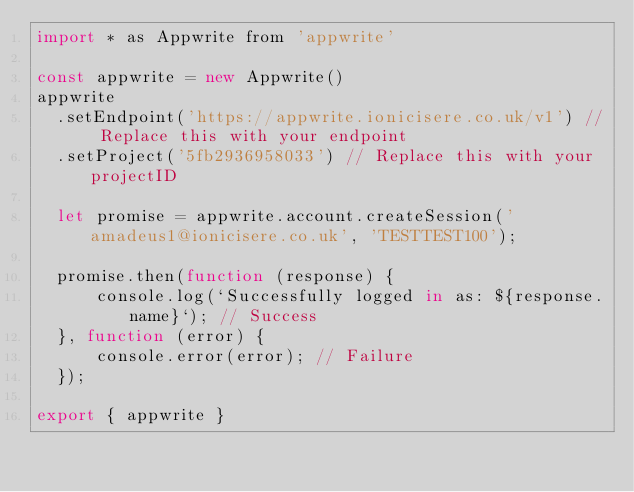<code> <loc_0><loc_0><loc_500><loc_500><_JavaScript_>import * as Appwrite from 'appwrite'

const appwrite = new Appwrite()
appwrite
  .setEndpoint('https://appwrite.ionicisere.co.uk/v1') // Replace this with your endpoint
  .setProject('5fb2936958033') // Replace this with your projectID

  let promise = appwrite.account.createSession('amadeus1@ionicisere.co.uk', 'TESTTEST100');

  promise.then(function (response) {
      console.log(`Successfully logged in as: ${response.name}`); // Success
  }, function (error) {
      console.error(error); // Failure
  });

export { appwrite }
</code> 